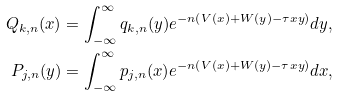Convert formula to latex. <formula><loc_0><loc_0><loc_500><loc_500>Q _ { k , n } ( x ) & = \int _ { - \infty } ^ { \infty } q _ { k , n } ( y ) e ^ { - n \left ( V ( x ) + W ( y ) - \tau x y \right ) } d y , \\ P _ { j , n } ( y ) & = \int _ { - \infty } ^ { \infty } p _ { j , n } ( x ) e ^ { - n \left ( V ( x ) + W ( y ) - \tau x y \right ) } d x ,</formula> 